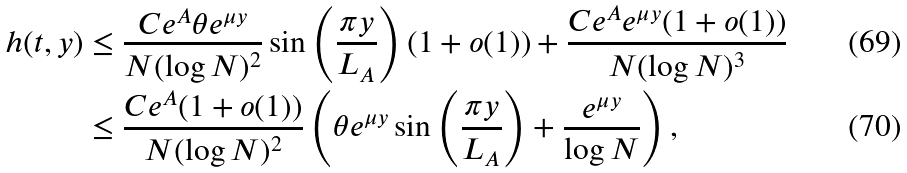<formula> <loc_0><loc_0><loc_500><loc_500>h ( t , y ) & \leq \frac { C e ^ { A } \theta e ^ { \mu y } } { N ( \log N ) ^ { 2 } } \sin \left ( \frac { \pi y } { L _ { A } } \right ) ( 1 + o ( 1 ) ) + \frac { C e ^ { A } e ^ { \mu y } ( 1 + o ( 1 ) ) } { N ( \log N ) ^ { 3 } } \\ & \leq \frac { C e ^ { A } ( 1 + o ( 1 ) ) } { N ( \log N ) ^ { 2 } } \left ( \theta e ^ { \mu y } \sin \left ( \frac { \pi y } { L _ { A } } \right ) + \frac { e ^ { \mu y } } { \log N } \right ) ,</formula> 